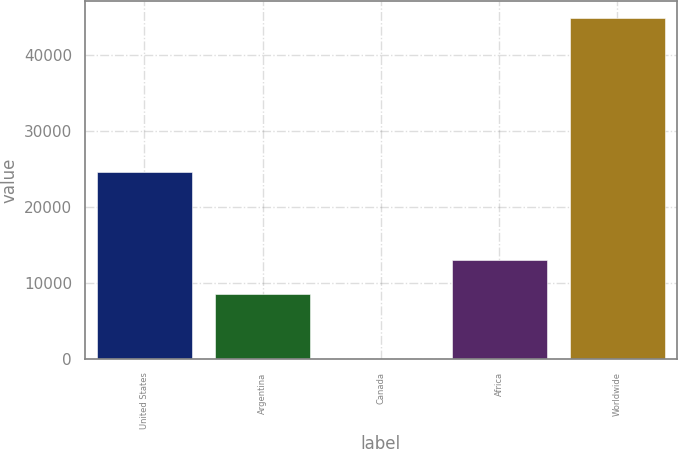<chart> <loc_0><loc_0><loc_500><loc_500><bar_chart><fcel>United States<fcel>Argentina<fcel>Canada<fcel>Africa<fcel>Worldwide<nl><fcel>24700<fcel>8534<fcel>72<fcel>13025<fcel>44982<nl></chart> 